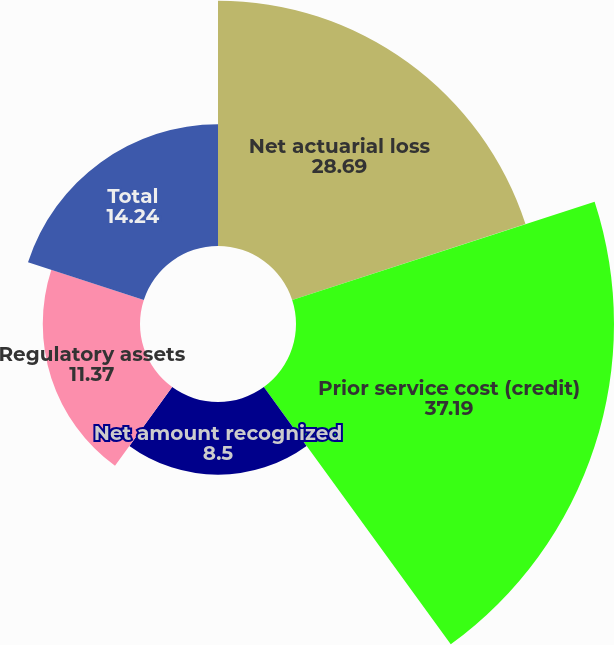<chart> <loc_0><loc_0><loc_500><loc_500><pie_chart><fcel>Net actuarial loss<fcel>Prior service cost (credit)<fcel>Net amount recognized<fcel>Regulatory assets<fcel>Total<nl><fcel>28.69%<fcel>37.19%<fcel>8.5%<fcel>11.37%<fcel>14.24%<nl></chart> 